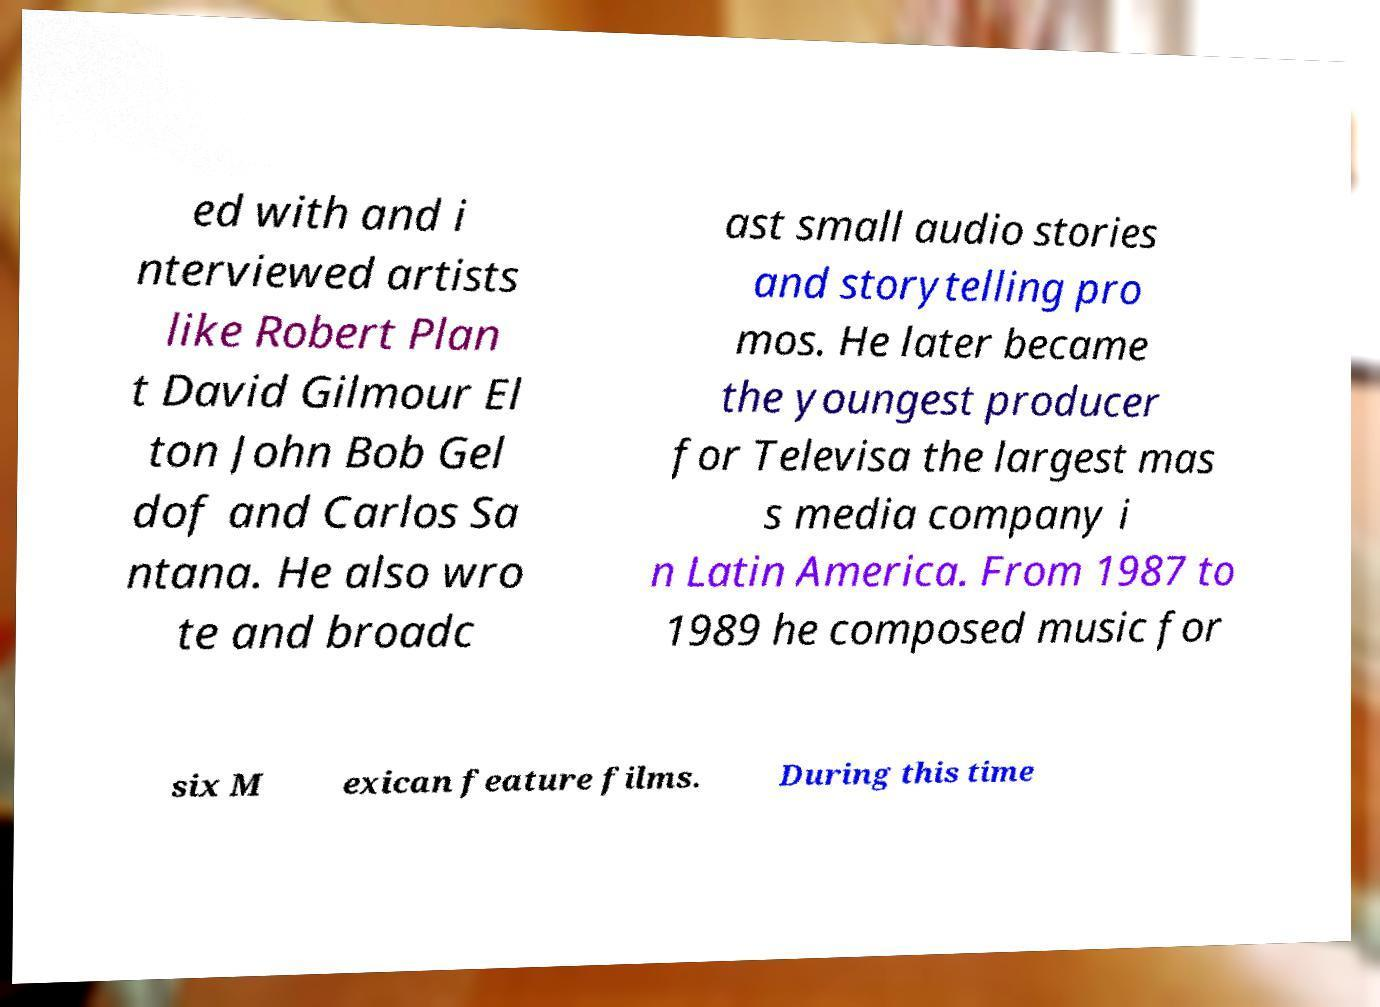What messages or text are displayed in this image? I need them in a readable, typed format. ed with and i nterviewed artists like Robert Plan t David Gilmour El ton John Bob Gel dof and Carlos Sa ntana. He also wro te and broadc ast small audio stories and storytelling pro mos. He later became the youngest producer for Televisa the largest mas s media company i n Latin America. From 1987 to 1989 he composed music for six M exican feature films. During this time 